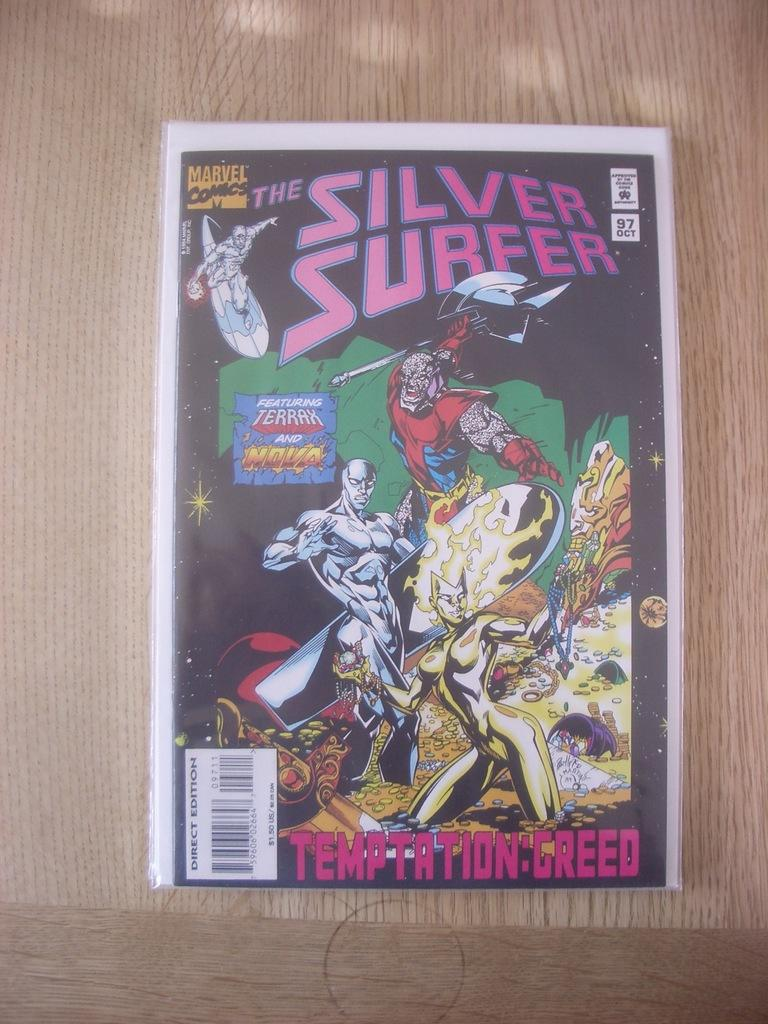<image>
Offer a succinct explanation of the picture presented. Marvel Comic book called the Silver Surfer lies on a piece of wood. 